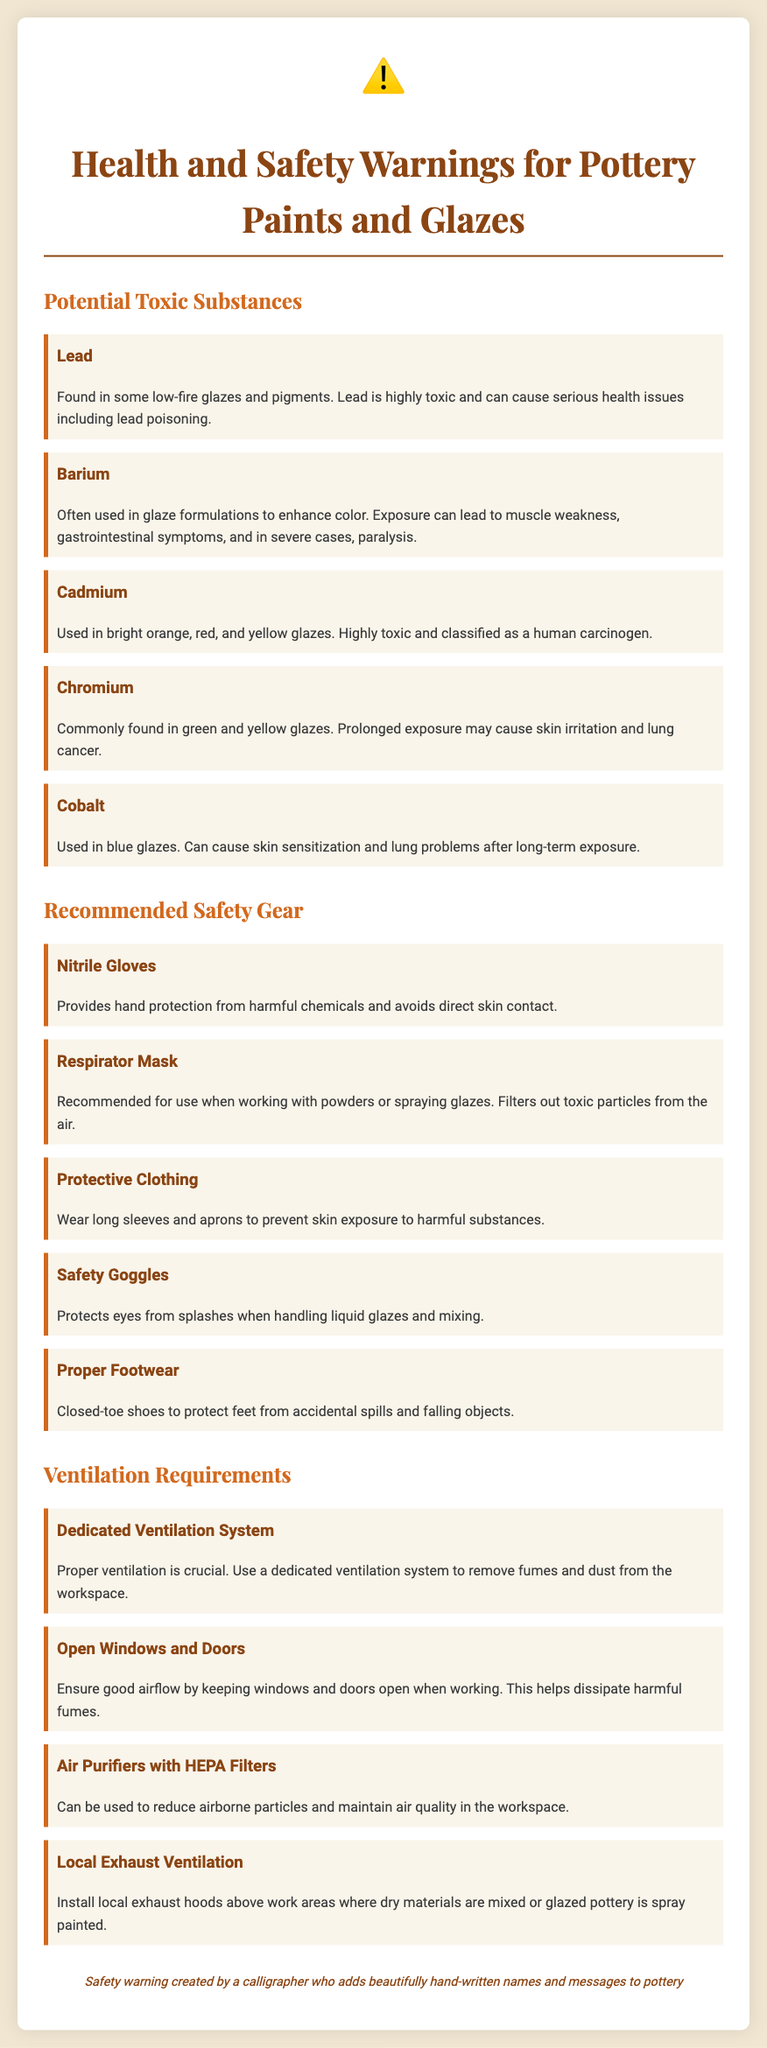What are some potential toxic substances in pottery paints? The document lists various toxic substances such as Lead, Barium, Cadmium, Chromium, and Cobalt.
Answer: Lead, Barium, Cadmium, Chromium, Cobalt What type of gloves are recommended for safety? The document specifies that nitrile gloves are recommended for hand protection from harmful chemicals.
Answer: Nitrile Gloves What health issue is associated with lead exposure? The document states that lead exposure can cause serious health issues including lead poisoning.
Answer: Lead poisoning How many ventilation requirements are listed in the document? The document lists four ventilation requirements for safe usage of pottery paints and glazes.
Answer: Four Which toxic substance is classified as a human carcinogen? The document mentions that cadmium is classified as a human carcinogen.
Answer: Cadmium What is recommended for use when working with powders? The document recommends a respirator mask for use when working with powders or spraying glazes.
Answer: Respirator Mask What type of clothing should be worn for protection? The document advises wearing long sleeves and aprons to prevent skin exposure to harmful substances.
Answer: Protective Clothing What equipment can reduce airborne particles? The document mentions using air purifiers with HEPA filters to reduce airborne particles.
Answer: Air Purifiers with HEPA Filters 